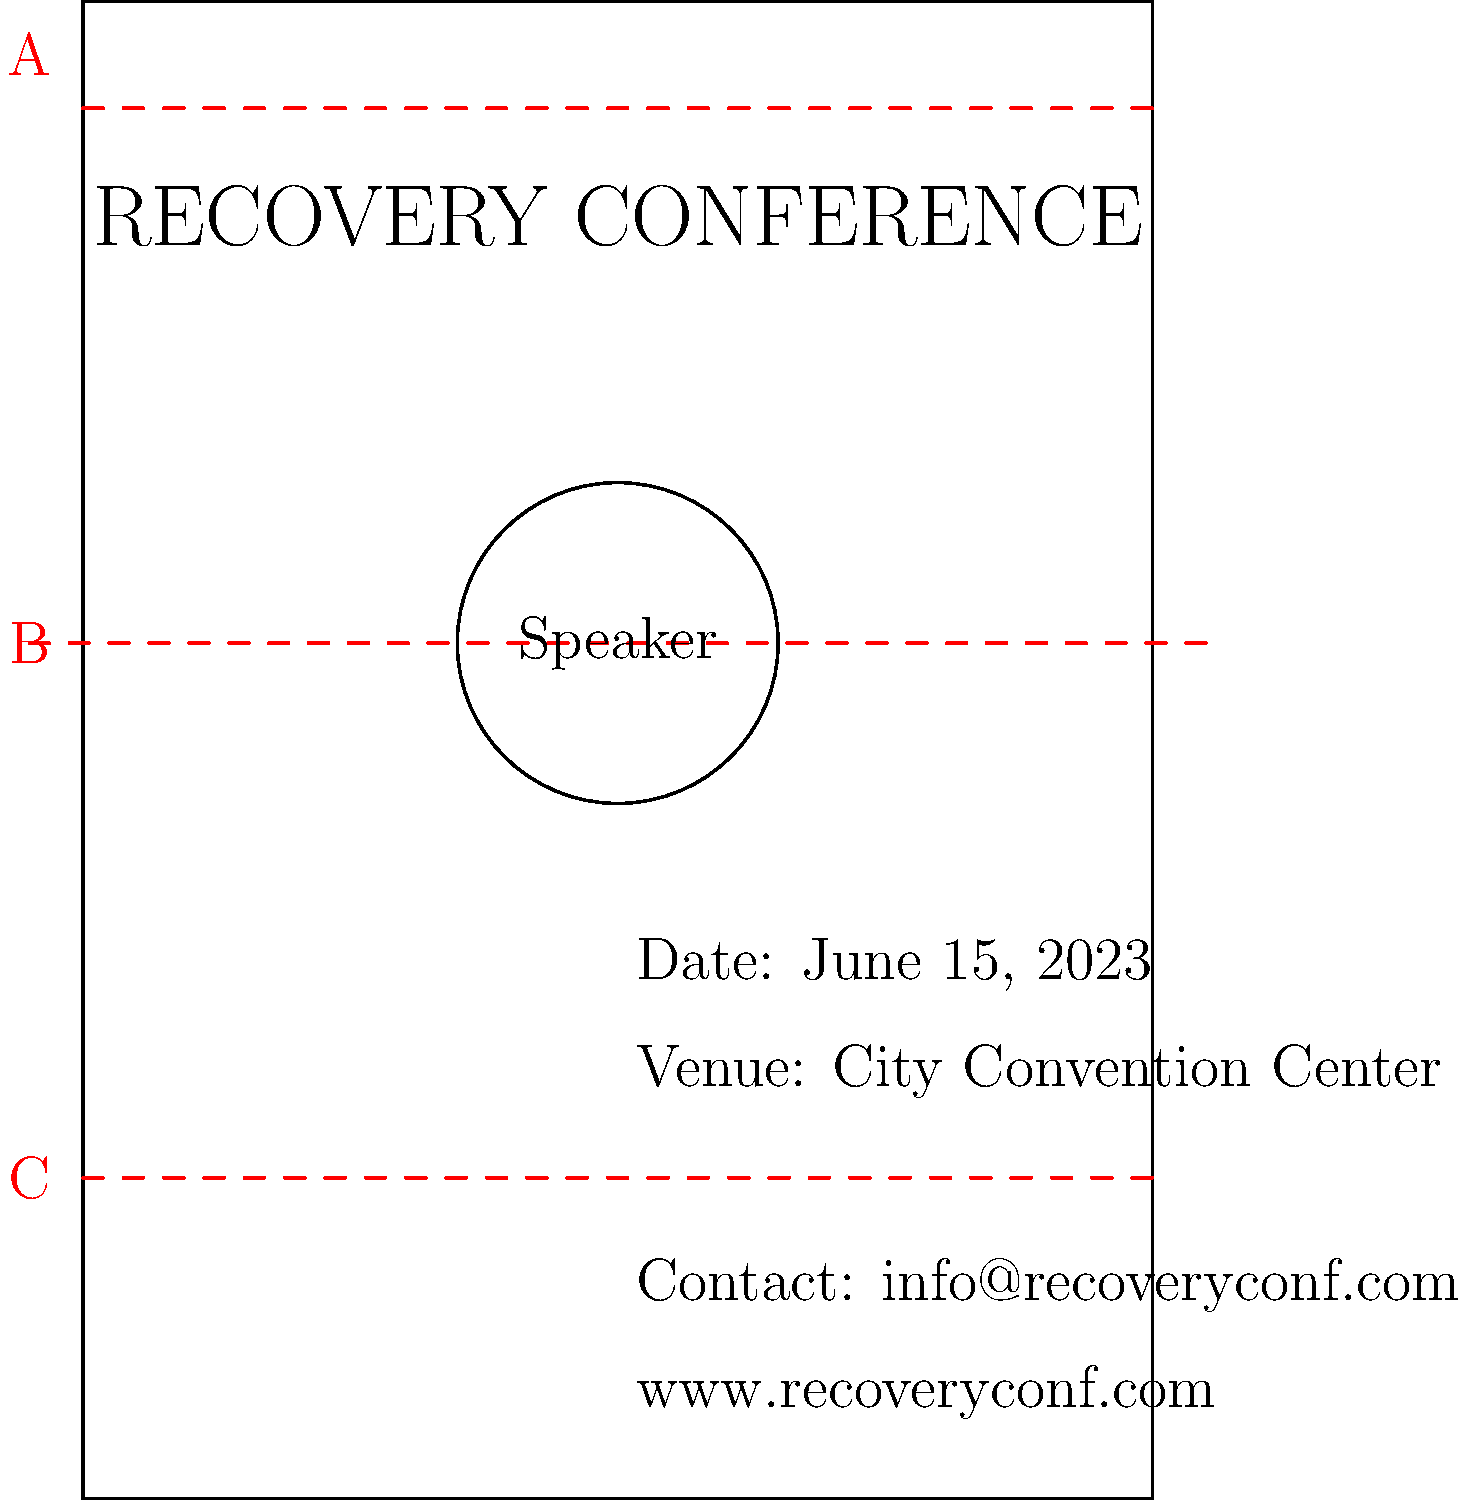As a PR specialist working on a Recovery Conference poster, which key elements should be highlighted in sections A, B, and C to create an effective and visually appealing design? To create an effective and visually appealing event poster for the Recovery Conference, we need to consider the following key elements for each section:

1. Section A (Top):
   - This is the prime location for the event title and main message.
   - It should contain the conference name "Recovery Conference" in large, bold text.
   - You may also include a subtitle or tagline that emphasizes the theme of recovery.

2. Section B (Middle):
   - This section should feature the main visual element, typically an image of the keynote speaker or a symbolic representation of recovery.
   - Include the speaker's name and a brief credential or achievement to add credibility.
   - If multiple speakers are featured, use small headshots with names.

3. Section C (Bottom):
   - This area is crucial for practical information.
   - Include the date, time, and venue of the conference.
   - Provide contact information and website details for further inquiries or registration.
   - You may also add sponsor logos or a call-to-action in this section.

By organizing the poster in this way, you create a logical flow of information:
1. Grab attention with the title (A)
2. Provide visual interest and credibility (B)
3. Give practical details for action (C)

This structure ensures that the poster is both informative and visually appealing, effectively promoting the Recovery Conference and the speaker's story.
Answer: A: Event title, B: Speaker image/info, C: Date, venue, contact details 